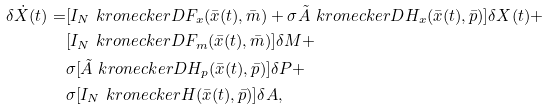Convert formula to latex. <formula><loc_0><loc_0><loc_500><loc_500>\delta \dot { X } ( t ) = & [ I _ { N } \ k r o n e c k e r D F _ { x } ( \bar { x } ( t ) , \bar { m } ) + \sigma \tilde { A } \ k r o n e c k e r D H _ { x } ( \bar { x } ( t ) , \bar { p } ) ] \delta { X } ( t ) + \\ & [ I _ { N } \ k r o n e c k e r D F _ { m } ( \bar { x } ( t ) , \bar { m } ) ] \delta { M } + \\ & \sigma [ \tilde { A } \ k r o n e c k e r D H _ { p } ( \bar { x } ( t ) , \bar { p } ) ] \delta { P } + \\ & \sigma [ I _ { N } \ k r o n e c k e r H ( \bar { x } ( t ) , \bar { p } ) ] \delta { A } ,</formula> 